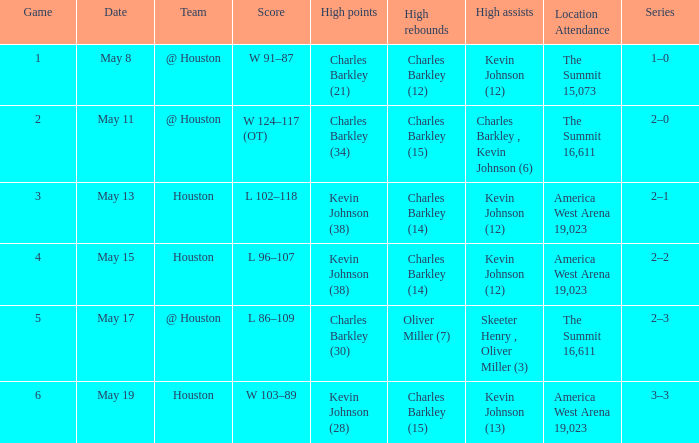Who did the high assists in the game where Charles Barkley (21) did the high points? Kevin Johnson (12). 